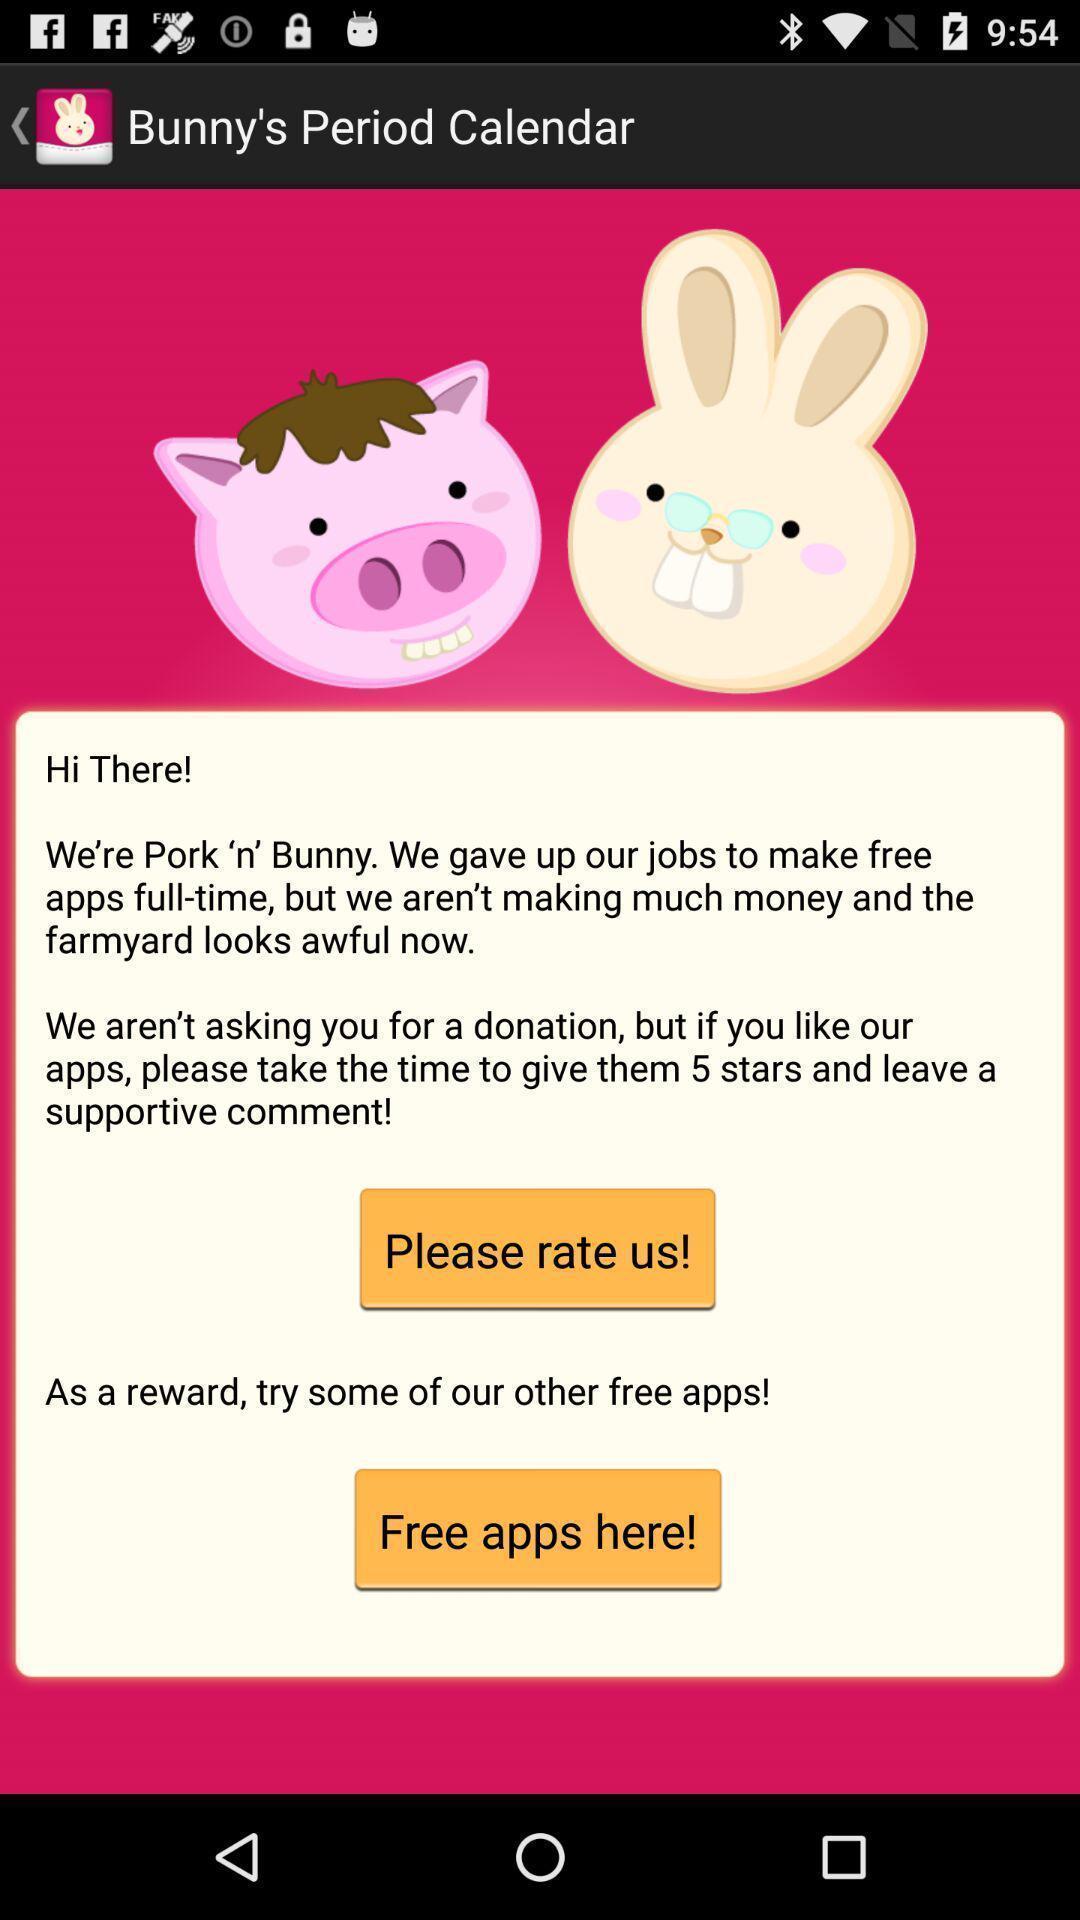Describe the content in this image. Screen displaying contents in feedback page. 